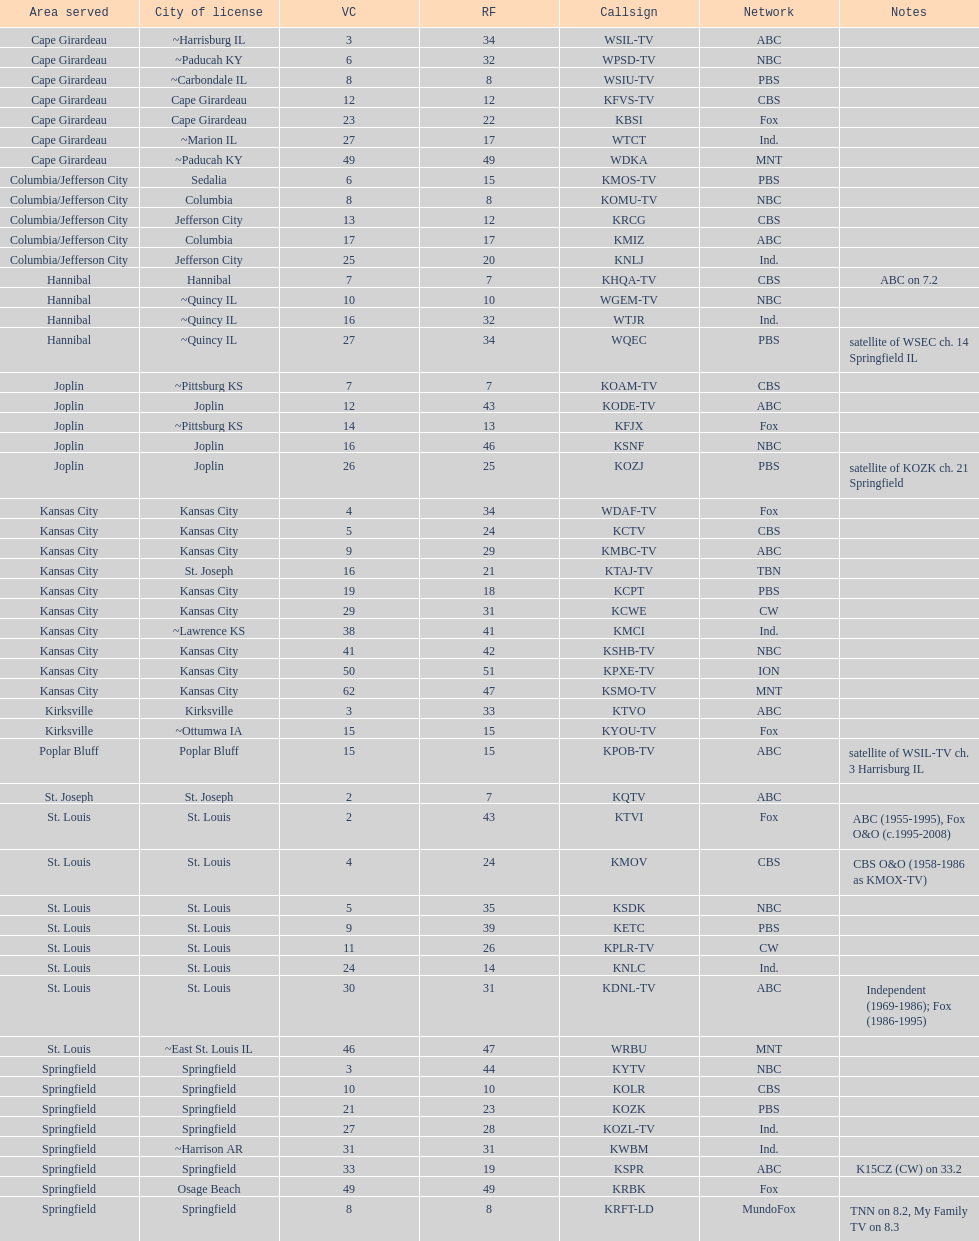What is the cumulative number of cbs stations? 7. 